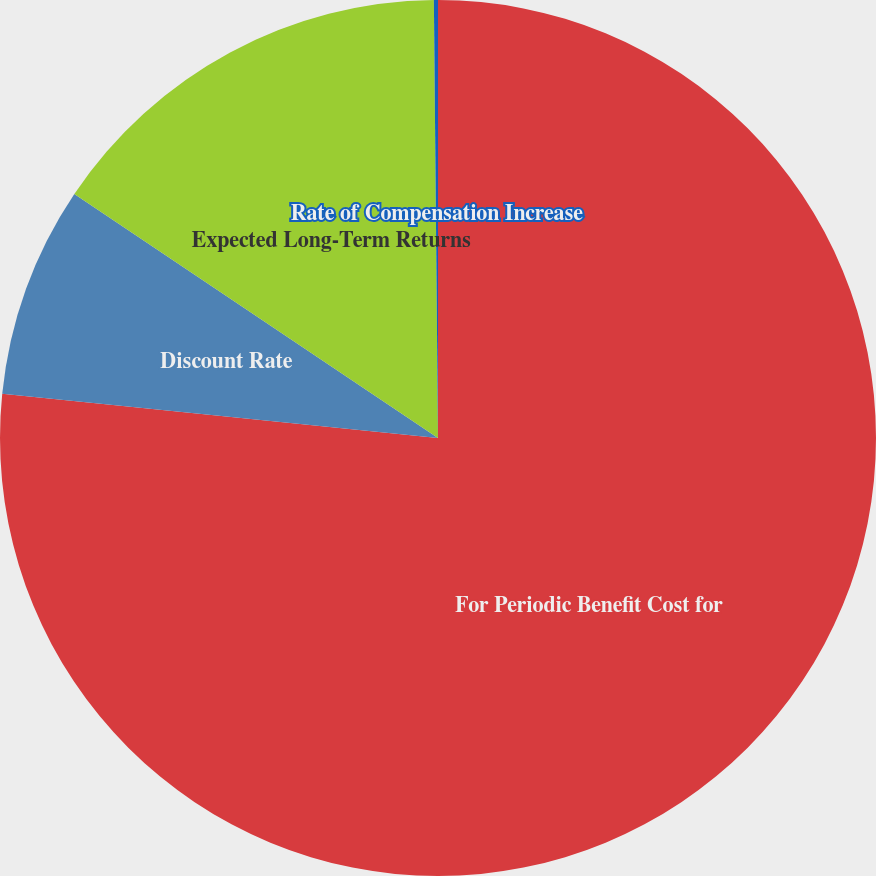Convert chart. <chart><loc_0><loc_0><loc_500><loc_500><pie_chart><fcel>For Periodic Benefit Cost for<fcel>Discount Rate<fcel>Expected Long-Term Returns<fcel>Rate of Compensation Increase<nl><fcel>76.6%<fcel>7.8%<fcel>15.44%<fcel>0.15%<nl></chart> 